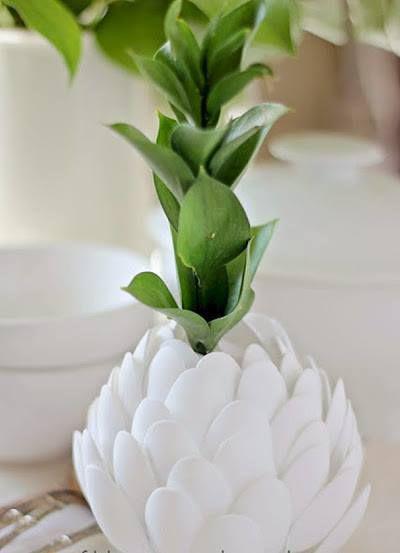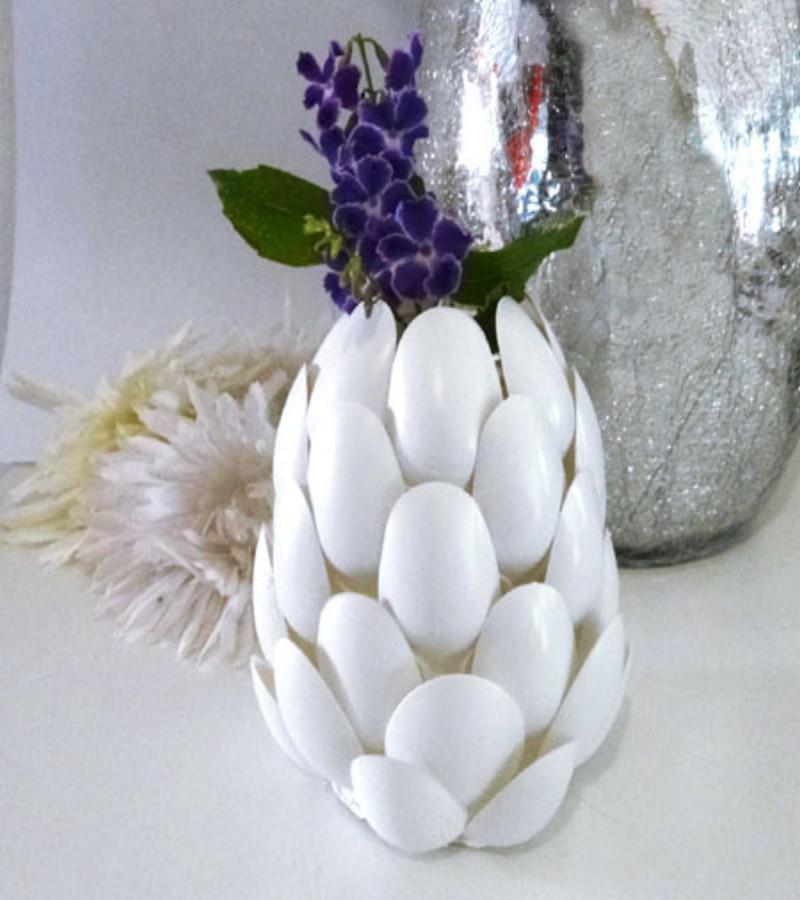The first image is the image on the left, the second image is the image on the right. Considering the images on both sides, is "The left image contains an entirely green plant in an artichoke-shaped vase, and the right image contains a purple-flowered plant in an artichoke-shaped vase." valid? Answer yes or no. Yes. The first image is the image on the left, the second image is the image on the right. For the images shown, is this caption "Two artichoke shaped vases contain plants." true? Answer yes or no. Yes. 